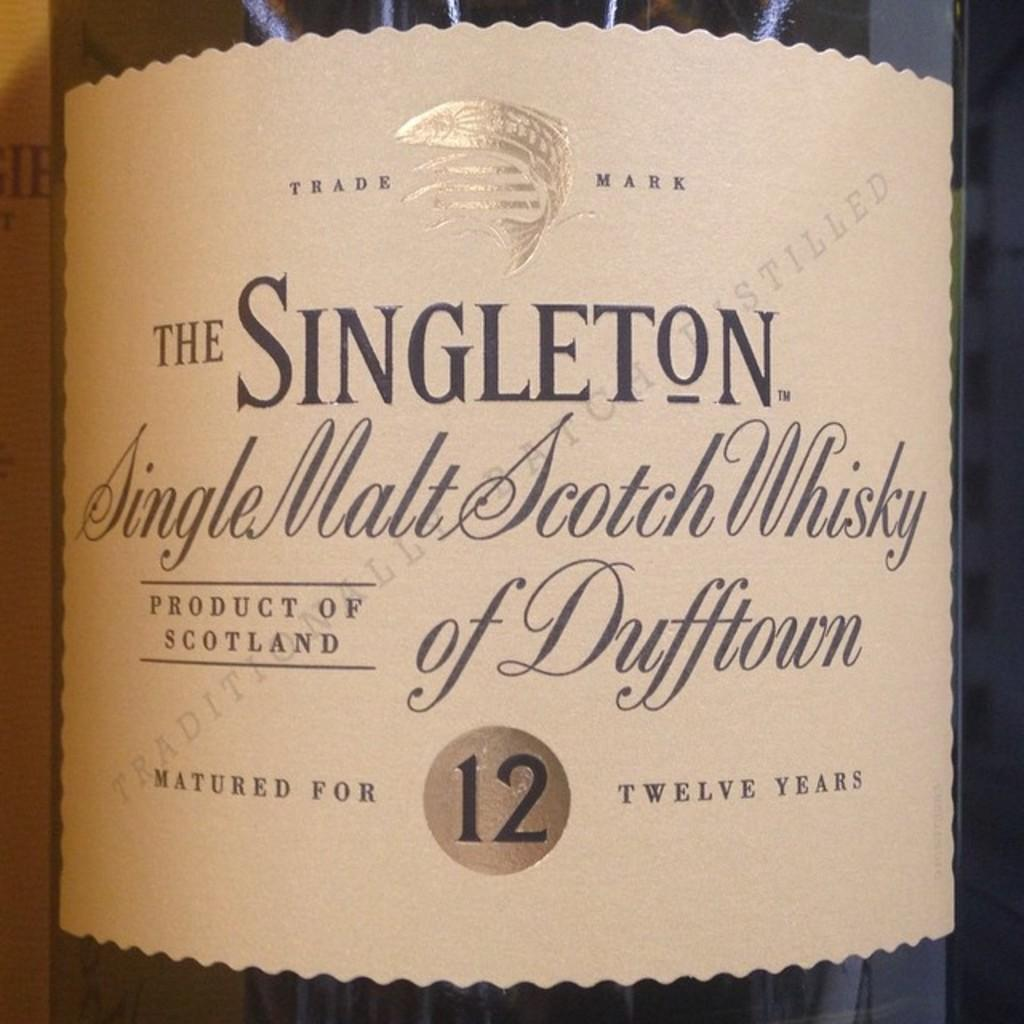What object is located in the foreground of the image? There is a bottle in the foreground of the image. What is covering the bottle? There is a paper wrapped around the bottle. Can you read any text on the paper? Yes, text is visible on the paper. What type of train can be seen passing by in the image? There is no train present in the image; it only features a bottle with a paper wrapped around it. What brand of jeans is visible on the person in the image? There is no person or jeans present in the image. 